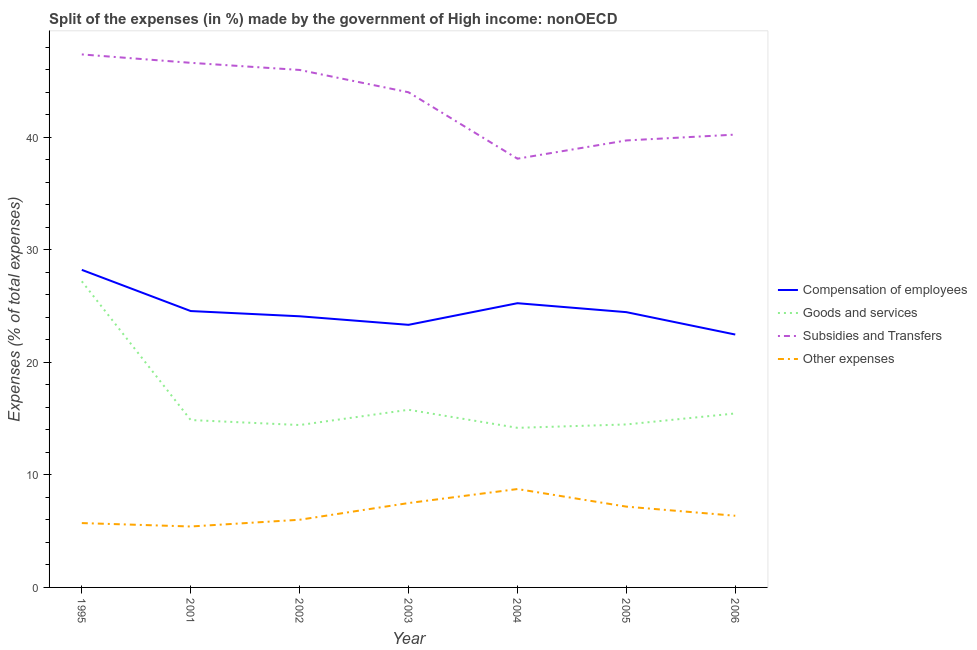Does the line corresponding to percentage of amount spent on compensation of employees intersect with the line corresponding to percentage of amount spent on goods and services?
Keep it short and to the point. No. What is the percentage of amount spent on goods and services in 2002?
Provide a short and direct response. 14.43. Across all years, what is the maximum percentage of amount spent on goods and services?
Your answer should be very brief. 27.2. Across all years, what is the minimum percentage of amount spent on goods and services?
Ensure brevity in your answer.  14.18. What is the total percentage of amount spent on subsidies in the graph?
Your answer should be very brief. 301.95. What is the difference between the percentage of amount spent on other expenses in 2001 and that in 2003?
Your answer should be compact. -2.08. What is the difference between the percentage of amount spent on compensation of employees in 2004 and the percentage of amount spent on other expenses in 2001?
Your answer should be compact. 19.84. What is the average percentage of amount spent on goods and services per year?
Keep it short and to the point. 16.63. In the year 2001, what is the difference between the percentage of amount spent on other expenses and percentage of amount spent on compensation of employees?
Keep it short and to the point. -19.14. In how many years, is the percentage of amount spent on goods and services greater than 44 %?
Make the answer very short. 0. What is the ratio of the percentage of amount spent on compensation of employees in 2002 to that in 2005?
Give a very brief answer. 0.99. Is the difference between the percentage of amount spent on subsidies in 2002 and 2006 greater than the difference between the percentage of amount spent on goods and services in 2002 and 2006?
Your answer should be compact. Yes. What is the difference between the highest and the second highest percentage of amount spent on other expenses?
Provide a succinct answer. 1.25. What is the difference between the highest and the lowest percentage of amount spent on subsidies?
Provide a short and direct response. 9.26. Is the sum of the percentage of amount spent on subsidies in 2001 and 2003 greater than the maximum percentage of amount spent on other expenses across all years?
Your response must be concise. Yes. Is it the case that in every year, the sum of the percentage of amount spent on goods and services and percentage of amount spent on other expenses is greater than the sum of percentage of amount spent on subsidies and percentage of amount spent on compensation of employees?
Your answer should be compact. No. Does the percentage of amount spent on subsidies monotonically increase over the years?
Give a very brief answer. No. Is the percentage of amount spent on other expenses strictly less than the percentage of amount spent on goods and services over the years?
Your answer should be very brief. Yes. How many lines are there?
Your answer should be very brief. 4. How many years are there in the graph?
Keep it short and to the point. 7. Are the values on the major ticks of Y-axis written in scientific E-notation?
Give a very brief answer. No. Does the graph contain any zero values?
Offer a terse response. No. Does the graph contain grids?
Give a very brief answer. No. What is the title of the graph?
Provide a succinct answer. Split of the expenses (in %) made by the government of High income: nonOECD. What is the label or title of the Y-axis?
Give a very brief answer. Expenses (% of total expenses). What is the Expenses (% of total expenses) of Compensation of employees in 1995?
Ensure brevity in your answer.  28.21. What is the Expenses (% of total expenses) in Goods and services in 1995?
Your answer should be very brief. 27.2. What is the Expenses (% of total expenses) of Subsidies and Transfers in 1995?
Your answer should be compact. 47.35. What is the Expenses (% of total expenses) in Other expenses in 1995?
Your response must be concise. 5.72. What is the Expenses (% of total expenses) in Compensation of employees in 2001?
Offer a very short reply. 24.55. What is the Expenses (% of total expenses) of Goods and services in 2001?
Keep it short and to the point. 14.87. What is the Expenses (% of total expenses) of Subsidies and Transfers in 2001?
Give a very brief answer. 46.61. What is the Expenses (% of total expenses) in Other expenses in 2001?
Make the answer very short. 5.41. What is the Expenses (% of total expenses) of Compensation of employees in 2002?
Ensure brevity in your answer.  24.09. What is the Expenses (% of total expenses) of Goods and services in 2002?
Provide a short and direct response. 14.43. What is the Expenses (% of total expenses) in Subsidies and Transfers in 2002?
Keep it short and to the point. 45.97. What is the Expenses (% of total expenses) in Other expenses in 2002?
Give a very brief answer. 6.01. What is the Expenses (% of total expenses) in Compensation of employees in 2003?
Provide a short and direct response. 23.33. What is the Expenses (% of total expenses) in Goods and services in 2003?
Give a very brief answer. 15.78. What is the Expenses (% of total expenses) in Subsidies and Transfers in 2003?
Your response must be concise. 43.99. What is the Expenses (% of total expenses) in Other expenses in 2003?
Make the answer very short. 7.5. What is the Expenses (% of total expenses) of Compensation of employees in 2004?
Offer a terse response. 25.25. What is the Expenses (% of total expenses) in Goods and services in 2004?
Offer a terse response. 14.18. What is the Expenses (% of total expenses) in Subsidies and Transfers in 2004?
Make the answer very short. 38.09. What is the Expenses (% of total expenses) in Other expenses in 2004?
Your response must be concise. 8.74. What is the Expenses (% of total expenses) in Compensation of employees in 2005?
Offer a terse response. 24.46. What is the Expenses (% of total expenses) in Goods and services in 2005?
Offer a very short reply. 14.48. What is the Expenses (% of total expenses) of Subsidies and Transfers in 2005?
Offer a terse response. 39.71. What is the Expenses (% of total expenses) in Other expenses in 2005?
Your answer should be compact. 7.18. What is the Expenses (% of total expenses) in Compensation of employees in 2006?
Keep it short and to the point. 22.47. What is the Expenses (% of total expenses) of Goods and services in 2006?
Keep it short and to the point. 15.46. What is the Expenses (% of total expenses) in Subsidies and Transfers in 2006?
Offer a terse response. 40.23. What is the Expenses (% of total expenses) of Other expenses in 2006?
Make the answer very short. 6.37. Across all years, what is the maximum Expenses (% of total expenses) of Compensation of employees?
Make the answer very short. 28.21. Across all years, what is the maximum Expenses (% of total expenses) of Goods and services?
Ensure brevity in your answer.  27.2. Across all years, what is the maximum Expenses (% of total expenses) in Subsidies and Transfers?
Keep it short and to the point. 47.35. Across all years, what is the maximum Expenses (% of total expenses) in Other expenses?
Provide a short and direct response. 8.74. Across all years, what is the minimum Expenses (% of total expenses) of Compensation of employees?
Your answer should be compact. 22.47. Across all years, what is the minimum Expenses (% of total expenses) of Goods and services?
Your answer should be compact. 14.18. Across all years, what is the minimum Expenses (% of total expenses) in Subsidies and Transfers?
Offer a very short reply. 38.09. Across all years, what is the minimum Expenses (% of total expenses) of Other expenses?
Your answer should be very brief. 5.41. What is the total Expenses (% of total expenses) in Compensation of employees in the graph?
Make the answer very short. 172.36. What is the total Expenses (% of total expenses) in Goods and services in the graph?
Your answer should be compact. 116.39. What is the total Expenses (% of total expenses) of Subsidies and Transfers in the graph?
Keep it short and to the point. 301.95. What is the total Expenses (% of total expenses) in Other expenses in the graph?
Offer a very short reply. 46.92. What is the difference between the Expenses (% of total expenses) of Compensation of employees in 1995 and that in 2001?
Your answer should be very brief. 3.66. What is the difference between the Expenses (% of total expenses) in Goods and services in 1995 and that in 2001?
Offer a terse response. 12.33. What is the difference between the Expenses (% of total expenses) of Subsidies and Transfers in 1995 and that in 2001?
Provide a succinct answer. 0.75. What is the difference between the Expenses (% of total expenses) of Other expenses in 1995 and that in 2001?
Your answer should be very brief. 0.3. What is the difference between the Expenses (% of total expenses) in Compensation of employees in 1995 and that in 2002?
Your answer should be very brief. 4.12. What is the difference between the Expenses (% of total expenses) of Goods and services in 1995 and that in 2002?
Provide a short and direct response. 12.77. What is the difference between the Expenses (% of total expenses) in Subsidies and Transfers in 1995 and that in 2002?
Offer a very short reply. 1.38. What is the difference between the Expenses (% of total expenses) of Other expenses in 1995 and that in 2002?
Make the answer very short. -0.3. What is the difference between the Expenses (% of total expenses) in Compensation of employees in 1995 and that in 2003?
Your answer should be very brief. 4.88. What is the difference between the Expenses (% of total expenses) of Goods and services in 1995 and that in 2003?
Make the answer very short. 11.41. What is the difference between the Expenses (% of total expenses) in Subsidies and Transfers in 1995 and that in 2003?
Offer a terse response. 3.36. What is the difference between the Expenses (% of total expenses) in Other expenses in 1995 and that in 2003?
Your answer should be very brief. -1.78. What is the difference between the Expenses (% of total expenses) in Compensation of employees in 1995 and that in 2004?
Provide a short and direct response. 2.96. What is the difference between the Expenses (% of total expenses) in Goods and services in 1995 and that in 2004?
Give a very brief answer. 13.02. What is the difference between the Expenses (% of total expenses) in Subsidies and Transfers in 1995 and that in 2004?
Keep it short and to the point. 9.26. What is the difference between the Expenses (% of total expenses) of Other expenses in 1995 and that in 2004?
Offer a terse response. -3.02. What is the difference between the Expenses (% of total expenses) in Compensation of employees in 1995 and that in 2005?
Your answer should be very brief. 3.76. What is the difference between the Expenses (% of total expenses) in Goods and services in 1995 and that in 2005?
Make the answer very short. 12.72. What is the difference between the Expenses (% of total expenses) of Subsidies and Transfers in 1995 and that in 2005?
Provide a succinct answer. 7.64. What is the difference between the Expenses (% of total expenses) in Other expenses in 1995 and that in 2005?
Provide a short and direct response. -1.46. What is the difference between the Expenses (% of total expenses) of Compensation of employees in 1995 and that in 2006?
Provide a succinct answer. 5.75. What is the difference between the Expenses (% of total expenses) of Goods and services in 1995 and that in 2006?
Ensure brevity in your answer.  11.74. What is the difference between the Expenses (% of total expenses) of Subsidies and Transfers in 1995 and that in 2006?
Ensure brevity in your answer.  7.12. What is the difference between the Expenses (% of total expenses) in Other expenses in 1995 and that in 2006?
Offer a terse response. -0.65. What is the difference between the Expenses (% of total expenses) of Compensation of employees in 2001 and that in 2002?
Give a very brief answer. 0.46. What is the difference between the Expenses (% of total expenses) in Goods and services in 2001 and that in 2002?
Keep it short and to the point. 0.44. What is the difference between the Expenses (% of total expenses) of Subsidies and Transfers in 2001 and that in 2002?
Your answer should be very brief. 0.63. What is the difference between the Expenses (% of total expenses) of Other expenses in 2001 and that in 2002?
Keep it short and to the point. -0.6. What is the difference between the Expenses (% of total expenses) of Compensation of employees in 2001 and that in 2003?
Offer a terse response. 1.22. What is the difference between the Expenses (% of total expenses) in Goods and services in 2001 and that in 2003?
Ensure brevity in your answer.  -0.91. What is the difference between the Expenses (% of total expenses) in Subsidies and Transfers in 2001 and that in 2003?
Offer a terse response. 2.62. What is the difference between the Expenses (% of total expenses) of Other expenses in 2001 and that in 2003?
Offer a terse response. -2.08. What is the difference between the Expenses (% of total expenses) in Compensation of employees in 2001 and that in 2004?
Your response must be concise. -0.7. What is the difference between the Expenses (% of total expenses) of Goods and services in 2001 and that in 2004?
Your answer should be very brief. 0.69. What is the difference between the Expenses (% of total expenses) of Subsidies and Transfers in 2001 and that in 2004?
Offer a terse response. 8.52. What is the difference between the Expenses (% of total expenses) in Other expenses in 2001 and that in 2004?
Offer a very short reply. -3.33. What is the difference between the Expenses (% of total expenses) of Compensation of employees in 2001 and that in 2005?
Make the answer very short. 0.1. What is the difference between the Expenses (% of total expenses) in Goods and services in 2001 and that in 2005?
Your answer should be compact. 0.39. What is the difference between the Expenses (% of total expenses) of Subsidies and Transfers in 2001 and that in 2005?
Give a very brief answer. 6.9. What is the difference between the Expenses (% of total expenses) of Other expenses in 2001 and that in 2005?
Your answer should be compact. -1.76. What is the difference between the Expenses (% of total expenses) in Compensation of employees in 2001 and that in 2006?
Offer a terse response. 2.09. What is the difference between the Expenses (% of total expenses) in Goods and services in 2001 and that in 2006?
Keep it short and to the point. -0.58. What is the difference between the Expenses (% of total expenses) of Subsidies and Transfers in 2001 and that in 2006?
Offer a terse response. 6.38. What is the difference between the Expenses (% of total expenses) in Other expenses in 2001 and that in 2006?
Keep it short and to the point. -0.95. What is the difference between the Expenses (% of total expenses) in Compensation of employees in 2002 and that in 2003?
Your response must be concise. 0.76. What is the difference between the Expenses (% of total expenses) of Goods and services in 2002 and that in 2003?
Provide a succinct answer. -1.36. What is the difference between the Expenses (% of total expenses) of Subsidies and Transfers in 2002 and that in 2003?
Your response must be concise. 1.98. What is the difference between the Expenses (% of total expenses) in Other expenses in 2002 and that in 2003?
Make the answer very short. -1.48. What is the difference between the Expenses (% of total expenses) of Compensation of employees in 2002 and that in 2004?
Offer a very short reply. -1.16. What is the difference between the Expenses (% of total expenses) of Goods and services in 2002 and that in 2004?
Keep it short and to the point. 0.25. What is the difference between the Expenses (% of total expenses) of Subsidies and Transfers in 2002 and that in 2004?
Keep it short and to the point. 7.88. What is the difference between the Expenses (% of total expenses) in Other expenses in 2002 and that in 2004?
Your response must be concise. -2.73. What is the difference between the Expenses (% of total expenses) of Compensation of employees in 2002 and that in 2005?
Offer a terse response. -0.37. What is the difference between the Expenses (% of total expenses) in Goods and services in 2002 and that in 2005?
Your answer should be very brief. -0.05. What is the difference between the Expenses (% of total expenses) of Subsidies and Transfers in 2002 and that in 2005?
Offer a very short reply. 6.26. What is the difference between the Expenses (% of total expenses) of Other expenses in 2002 and that in 2005?
Give a very brief answer. -1.17. What is the difference between the Expenses (% of total expenses) of Compensation of employees in 2002 and that in 2006?
Keep it short and to the point. 1.62. What is the difference between the Expenses (% of total expenses) of Goods and services in 2002 and that in 2006?
Give a very brief answer. -1.03. What is the difference between the Expenses (% of total expenses) of Subsidies and Transfers in 2002 and that in 2006?
Your response must be concise. 5.74. What is the difference between the Expenses (% of total expenses) in Other expenses in 2002 and that in 2006?
Give a very brief answer. -0.35. What is the difference between the Expenses (% of total expenses) of Compensation of employees in 2003 and that in 2004?
Ensure brevity in your answer.  -1.92. What is the difference between the Expenses (% of total expenses) of Goods and services in 2003 and that in 2004?
Your response must be concise. 1.6. What is the difference between the Expenses (% of total expenses) in Subsidies and Transfers in 2003 and that in 2004?
Ensure brevity in your answer.  5.9. What is the difference between the Expenses (% of total expenses) in Other expenses in 2003 and that in 2004?
Offer a very short reply. -1.25. What is the difference between the Expenses (% of total expenses) in Compensation of employees in 2003 and that in 2005?
Make the answer very short. -1.13. What is the difference between the Expenses (% of total expenses) in Goods and services in 2003 and that in 2005?
Offer a terse response. 1.3. What is the difference between the Expenses (% of total expenses) in Subsidies and Transfers in 2003 and that in 2005?
Give a very brief answer. 4.28. What is the difference between the Expenses (% of total expenses) in Other expenses in 2003 and that in 2005?
Make the answer very short. 0.32. What is the difference between the Expenses (% of total expenses) in Compensation of employees in 2003 and that in 2006?
Ensure brevity in your answer.  0.86. What is the difference between the Expenses (% of total expenses) of Goods and services in 2003 and that in 2006?
Keep it short and to the point. 0.33. What is the difference between the Expenses (% of total expenses) in Subsidies and Transfers in 2003 and that in 2006?
Offer a terse response. 3.76. What is the difference between the Expenses (% of total expenses) in Other expenses in 2003 and that in 2006?
Your answer should be very brief. 1.13. What is the difference between the Expenses (% of total expenses) in Compensation of employees in 2004 and that in 2005?
Ensure brevity in your answer.  0.79. What is the difference between the Expenses (% of total expenses) of Goods and services in 2004 and that in 2005?
Give a very brief answer. -0.3. What is the difference between the Expenses (% of total expenses) in Subsidies and Transfers in 2004 and that in 2005?
Offer a terse response. -1.62. What is the difference between the Expenses (% of total expenses) in Other expenses in 2004 and that in 2005?
Ensure brevity in your answer.  1.56. What is the difference between the Expenses (% of total expenses) of Compensation of employees in 2004 and that in 2006?
Give a very brief answer. 2.78. What is the difference between the Expenses (% of total expenses) of Goods and services in 2004 and that in 2006?
Offer a very short reply. -1.28. What is the difference between the Expenses (% of total expenses) of Subsidies and Transfers in 2004 and that in 2006?
Ensure brevity in your answer.  -2.14. What is the difference between the Expenses (% of total expenses) of Other expenses in 2004 and that in 2006?
Your answer should be very brief. 2.37. What is the difference between the Expenses (% of total expenses) of Compensation of employees in 2005 and that in 2006?
Offer a very short reply. 1.99. What is the difference between the Expenses (% of total expenses) in Goods and services in 2005 and that in 2006?
Keep it short and to the point. -0.98. What is the difference between the Expenses (% of total expenses) of Subsidies and Transfers in 2005 and that in 2006?
Your answer should be very brief. -0.52. What is the difference between the Expenses (% of total expenses) in Other expenses in 2005 and that in 2006?
Make the answer very short. 0.81. What is the difference between the Expenses (% of total expenses) of Compensation of employees in 1995 and the Expenses (% of total expenses) of Goods and services in 2001?
Offer a terse response. 13.34. What is the difference between the Expenses (% of total expenses) of Compensation of employees in 1995 and the Expenses (% of total expenses) of Subsidies and Transfers in 2001?
Provide a succinct answer. -18.39. What is the difference between the Expenses (% of total expenses) in Compensation of employees in 1995 and the Expenses (% of total expenses) in Other expenses in 2001?
Your answer should be very brief. 22.8. What is the difference between the Expenses (% of total expenses) in Goods and services in 1995 and the Expenses (% of total expenses) in Subsidies and Transfers in 2001?
Ensure brevity in your answer.  -19.41. What is the difference between the Expenses (% of total expenses) of Goods and services in 1995 and the Expenses (% of total expenses) of Other expenses in 2001?
Offer a terse response. 21.78. What is the difference between the Expenses (% of total expenses) in Subsidies and Transfers in 1995 and the Expenses (% of total expenses) in Other expenses in 2001?
Give a very brief answer. 41.94. What is the difference between the Expenses (% of total expenses) of Compensation of employees in 1995 and the Expenses (% of total expenses) of Goods and services in 2002?
Ensure brevity in your answer.  13.79. What is the difference between the Expenses (% of total expenses) in Compensation of employees in 1995 and the Expenses (% of total expenses) in Subsidies and Transfers in 2002?
Make the answer very short. -17.76. What is the difference between the Expenses (% of total expenses) of Compensation of employees in 1995 and the Expenses (% of total expenses) of Other expenses in 2002?
Provide a short and direct response. 22.2. What is the difference between the Expenses (% of total expenses) of Goods and services in 1995 and the Expenses (% of total expenses) of Subsidies and Transfers in 2002?
Offer a terse response. -18.78. What is the difference between the Expenses (% of total expenses) in Goods and services in 1995 and the Expenses (% of total expenses) in Other expenses in 2002?
Ensure brevity in your answer.  21.18. What is the difference between the Expenses (% of total expenses) in Subsidies and Transfers in 1995 and the Expenses (% of total expenses) in Other expenses in 2002?
Your answer should be very brief. 41.34. What is the difference between the Expenses (% of total expenses) in Compensation of employees in 1995 and the Expenses (% of total expenses) in Goods and services in 2003?
Give a very brief answer. 12.43. What is the difference between the Expenses (% of total expenses) of Compensation of employees in 1995 and the Expenses (% of total expenses) of Subsidies and Transfers in 2003?
Ensure brevity in your answer.  -15.78. What is the difference between the Expenses (% of total expenses) of Compensation of employees in 1995 and the Expenses (% of total expenses) of Other expenses in 2003?
Provide a succinct answer. 20.72. What is the difference between the Expenses (% of total expenses) in Goods and services in 1995 and the Expenses (% of total expenses) in Subsidies and Transfers in 2003?
Provide a short and direct response. -16.79. What is the difference between the Expenses (% of total expenses) in Goods and services in 1995 and the Expenses (% of total expenses) in Other expenses in 2003?
Your response must be concise. 19.7. What is the difference between the Expenses (% of total expenses) of Subsidies and Transfers in 1995 and the Expenses (% of total expenses) of Other expenses in 2003?
Give a very brief answer. 39.86. What is the difference between the Expenses (% of total expenses) in Compensation of employees in 1995 and the Expenses (% of total expenses) in Goods and services in 2004?
Make the answer very short. 14.03. What is the difference between the Expenses (% of total expenses) in Compensation of employees in 1995 and the Expenses (% of total expenses) in Subsidies and Transfers in 2004?
Keep it short and to the point. -9.88. What is the difference between the Expenses (% of total expenses) in Compensation of employees in 1995 and the Expenses (% of total expenses) in Other expenses in 2004?
Ensure brevity in your answer.  19.47. What is the difference between the Expenses (% of total expenses) of Goods and services in 1995 and the Expenses (% of total expenses) of Subsidies and Transfers in 2004?
Make the answer very short. -10.89. What is the difference between the Expenses (% of total expenses) in Goods and services in 1995 and the Expenses (% of total expenses) in Other expenses in 2004?
Provide a succinct answer. 18.46. What is the difference between the Expenses (% of total expenses) of Subsidies and Transfers in 1995 and the Expenses (% of total expenses) of Other expenses in 2004?
Provide a short and direct response. 38.61. What is the difference between the Expenses (% of total expenses) of Compensation of employees in 1995 and the Expenses (% of total expenses) of Goods and services in 2005?
Your response must be concise. 13.73. What is the difference between the Expenses (% of total expenses) in Compensation of employees in 1995 and the Expenses (% of total expenses) in Subsidies and Transfers in 2005?
Offer a terse response. -11.5. What is the difference between the Expenses (% of total expenses) of Compensation of employees in 1995 and the Expenses (% of total expenses) of Other expenses in 2005?
Provide a short and direct response. 21.04. What is the difference between the Expenses (% of total expenses) in Goods and services in 1995 and the Expenses (% of total expenses) in Subsidies and Transfers in 2005?
Provide a short and direct response. -12.51. What is the difference between the Expenses (% of total expenses) of Goods and services in 1995 and the Expenses (% of total expenses) of Other expenses in 2005?
Give a very brief answer. 20.02. What is the difference between the Expenses (% of total expenses) of Subsidies and Transfers in 1995 and the Expenses (% of total expenses) of Other expenses in 2005?
Ensure brevity in your answer.  40.17. What is the difference between the Expenses (% of total expenses) in Compensation of employees in 1995 and the Expenses (% of total expenses) in Goods and services in 2006?
Provide a succinct answer. 12.76. What is the difference between the Expenses (% of total expenses) in Compensation of employees in 1995 and the Expenses (% of total expenses) in Subsidies and Transfers in 2006?
Offer a very short reply. -12.02. What is the difference between the Expenses (% of total expenses) in Compensation of employees in 1995 and the Expenses (% of total expenses) in Other expenses in 2006?
Offer a very short reply. 21.85. What is the difference between the Expenses (% of total expenses) of Goods and services in 1995 and the Expenses (% of total expenses) of Subsidies and Transfers in 2006?
Ensure brevity in your answer.  -13.03. What is the difference between the Expenses (% of total expenses) in Goods and services in 1995 and the Expenses (% of total expenses) in Other expenses in 2006?
Give a very brief answer. 20.83. What is the difference between the Expenses (% of total expenses) of Subsidies and Transfers in 1995 and the Expenses (% of total expenses) of Other expenses in 2006?
Give a very brief answer. 40.99. What is the difference between the Expenses (% of total expenses) of Compensation of employees in 2001 and the Expenses (% of total expenses) of Goods and services in 2002?
Give a very brief answer. 10.13. What is the difference between the Expenses (% of total expenses) in Compensation of employees in 2001 and the Expenses (% of total expenses) in Subsidies and Transfers in 2002?
Offer a terse response. -21.42. What is the difference between the Expenses (% of total expenses) of Compensation of employees in 2001 and the Expenses (% of total expenses) of Other expenses in 2002?
Make the answer very short. 18.54. What is the difference between the Expenses (% of total expenses) in Goods and services in 2001 and the Expenses (% of total expenses) in Subsidies and Transfers in 2002?
Your answer should be very brief. -31.1. What is the difference between the Expenses (% of total expenses) in Goods and services in 2001 and the Expenses (% of total expenses) in Other expenses in 2002?
Make the answer very short. 8.86. What is the difference between the Expenses (% of total expenses) of Subsidies and Transfers in 2001 and the Expenses (% of total expenses) of Other expenses in 2002?
Give a very brief answer. 40.59. What is the difference between the Expenses (% of total expenses) of Compensation of employees in 2001 and the Expenses (% of total expenses) of Goods and services in 2003?
Ensure brevity in your answer.  8.77. What is the difference between the Expenses (% of total expenses) of Compensation of employees in 2001 and the Expenses (% of total expenses) of Subsidies and Transfers in 2003?
Give a very brief answer. -19.44. What is the difference between the Expenses (% of total expenses) of Compensation of employees in 2001 and the Expenses (% of total expenses) of Other expenses in 2003?
Provide a succinct answer. 17.06. What is the difference between the Expenses (% of total expenses) of Goods and services in 2001 and the Expenses (% of total expenses) of Subsidies and Transfers in 2003?
Your answer should be compact. -29.12. What is the difference between the Expenses (% of total expenses) in Goods and services in 2001 and the Expenses (% of total expenses) in Other expenses in 2003?
Your response must be concise. 7.38. What is the difference between the Expenses (% of total expenses) in Subsidies and Transfers in 2001 and the Expenses (% of total expenses) in Other expenses in 2003?
Offer a very short reply. 39.11. What is the difference between the Expenses (% of total expenses) of Compensation of employees in 2001 and the Expenses (% of total expenses) of Goods and services in 2004?
Ensure brevity in your answer.  10.38. What is the difference between the Expenses (% of total expenses) in Compensation of employees in 2001 and the Expenses (% of total expenses) in Subsidies and Transfers in 2004?
Keep it short and to the point. -13.54. What is the difference between the Expenses (% of total expenses) of Compensation of employees in 2001 and the Expenses (% of total expenses) of Other expenses in 2004?
Your response must be concise. 15.81. What is the difference between the Expenses (% of total expenses) in Goods and services in 2001 and the Expenses (% of total expenses) in Subsidies and Transfers in 2004?
Give a very brief answer. -23.22. What is the difference between the Expenses (% of total expenses) of Goods and services in 2001 and the Expenses (% of total expenses) of Other expenses in 2004?
Your response must be concise. 6.13. What is the difference between the Expenses (% of total expenses) of Subsidies and Transfers in 2001 and the Expenses (% of total expenses) of Other expenses in 2004?
Provide a short and direct response. 37.87. What is the difference between the Expenses (% of total expenses) in Compensation of employees in 2001 and the Expenses (% of total expenses) in Goods and services in 2005?
Your response must be concise. 10.08. What is the difference between the Expenses (% of total expenses) in Compensation of employees in 2001 and the Expenses (% of total expenses) in Subsidies and Transfers in 2005?
Your answer should be compact. -15.16. What is the difference between the Expenses (% of total expenses) in Compensation of employees in 2001 and the Expenses (% of total expenses) in Other expenses in 2005?
Provide a short and direct response. 17.38. What is the difference between the Expenses (% of total expenses) in Goods and services in 2001 and the Expenses (% of total expenses) in Subsidies and Transfers in 2005?
Give a very brief answer. -24.84. What is the difference between the Expenses (% of total expenses) in Goods and services in 2001 and the Expenses (% of total expenses) in Other expenses in 2005?
Make the answer very short. 7.69. What is the difference between the Expenses (% of total expenses) of Subsidies and Transfers in 2001 and the Expenses (% of total expenses) of Other expenses in 2005?
Your answer should be very brief. 39.43. What is the difference between the Expenses (% of total expenses) in Compensation of employees in 2001 and the Expenses (% of total expenses) in Goods and services in 2006?
Offer a very short reply. 9.1. What is the difference between the Expenses (% of total expenses) of Compensation of employees in 2001 and the Expenses (% of total expenses) of Subsidies and Transfers in 2006?
Your answer should be compact. -15.68. What is the difference between the Expenses (% of total expenses) in Compensation of employees in 2001 and the Expenses (% of total expenses) in Other expenses in 2006?
Your answer should be very brief. 18.19. What is the difference between the Expenses (% of total expenses) in Goods and services in 2001 and the Expenses (% of total expenses) in Subsidies and Transfers in 2006?
Offer a terse response. -25.36. What is the difference between the Expenses (% of total expenses) of Goods and services in 2001 and the Expenses (% of total expenses) of Other expenses in 2006?
Ensure brevity in your answer.  8.5. What is the difference between the Expenses (% of total expenses) in Subsidies and Transfers in 2001 and the Expenses (% of total expenses) in Other expenses in 2006?
Ensure brevity in your answer.  40.24. What is the difference between the Expenses (% of total expenses) in Compensation of employees in 2002 and the Expenses (% of total expenses) in Goods and services in 2003?
Offer a terse response. 8.31. What is the difference between the Expenses (% of total expenses) in Compensation of employees in 2002 and the Expenses (% of total expenses) in Subsidies and Transfers in 2003?
Your answer should be compact. -19.9. What is the difference between the Expenses (% of total expenses) of Compensation of employees in 2002 and the Expenses (% of total expenses) of Other expenses in 2003?
Provide a succinct answer. 16.59. What is the difference between the Expenses (% of total expenses) in Goods and services in 2002 and the Expenses (% of total expenses) in Subsidies and Transfers in 2003?
Your answer should be very brief. -29.56. What is the difference between the Expenses (% of total expenses) in Goods and services in 2002 and the Expenses (% of total expenses) in Other expenses in 2003?
Keep it short and to the point. 6.93. What is the difference between the Expenses (% of total expenses) in Subsidies and Transfers in 2002 and the Expenses (% of total expenses) in Other expenses in 2003?
Your response must be concise. 38.48. What is the difference between the Expenses (% of total expenses) in Compensation of employees in 2002 and the Expenses (% of total expenses) in Goods and services in 2004?
Provide a succinct answer. 9.91. What is the difference between the Expenses (% of total expenses) in Compensation of employees in 2002 and the Expenses (% of total expenses) in Subsidies and Transfers in 2004?
Your response must be concise. -14. What is the difference between the Expenses (% of total expenses) in Compensation of employees in 2002 and the Expenses (% of total expenses) in Other expenses in 2004?
Your answer should be very brief. 15.35. What is the difference between the Expenses (% of total expenses) of Goods and services in 2002 and the Expenses (% of total expenses) of Subsidies and Transfers in 2004?
Make the answer very short. -23.66. What is the difference between the Expenses (% of total expenses) in Goods and services in 2002 and the Expenses (% of total expenses) in Other expenses in 2004?
Ensure brevity in your answer.  5.69. What is the difference between the Expenses (% of total expenses) in Subsidies and Transfers in 2002 and the Expenses (% of total expenses) in Other expenses in 2004?
Offer a very short reply. 37.23. What is the difference between the Expenses (% of total expenses) in Compensation of employees in 2002 and the Expenses (% of total expenses) in Goods and services in 2005?
Give a very brief answer. 9.61. What is the difference between the Expenses (% of total expenses) in Compensation of employees in 2002 and the Expenses (% of total expenses) in Subsidies and Transfers in 2005?
Offer a very short reply. -15.62. What is the difference between the Expenses (% of total expenses) in Compensation of employees in 2002 and the Expenses (% of total expenses) in Other expenses in 2005?
Provide a succinct answer. 16.91. What is the difference between the Expenses (% of total expenses) in Goods and services in 2002 and the Expenses (% of total expenses) in Subsidies and Transfers in 2005?
Keep it short and to the point. -25.28. What is the difference between the Expenses (% of total expenses) in Goods and services in 2002 and the Expenses (% of total expenses) in Other expenses in 2005?
Provide a succinct answer. 7.25. What is the difference between the Expenses (% of total expenses) in Subsidies and Transfers in 2002 and the Expenses (% of total expenses) in Other expenses in 2005?
Give a very brief answer. 38.79. What is the difference between the Expenses (% of total expenses) in Compensation of employees in 2002 and the Expenses (% of total expenses) in Goods and services in 2006?
Make the answer very short. 8.63. What is the difference between the Expenses (% of total expenses) of Compensation of employees in 2002 and the Expenses (% of total expenses) of Subsidies and Transfers in 2006?
Provide a short and direct response. -16.14. What is the difference between the Expenses (% of total expenses) in Compensation of employees in 2002 and the Expenses (% of total expenses) in Other expenses in 2006?
Ensure brevity in your answer.  17.72. What is the difference between the Expenses (% of total expenses) of Goods and services in 2002 and the Expenses (% of total expenses) of Subsidies and Transfers in 2006?
Give a very brief answer. -25.8. What is the difference between the Expenses (% of total expenses) of Goods and services in 2002 and the Expenses (% of total expenses) of Other expenses in 2006?
Your answer should be very brief. 8.06. What is the difference between the Expenses (% of total expenses) of Subsidies and Transfers in 2002 and the Expenses (% of total expenses) of Other expenses in 2006?
Provide a succinct answer. 39.61. What is the difference between the Expenses (% of total expenses) of Compensation of employees in 2003 and the Expenses (% of total expenses) of Goods and services in 2004?
Make the answer very short. 9.15. What is the difference between the Expenses (% of total expenses) of Compensation of employees in 2003 and the Expenses (% of total expenses) of Subsidies and Transfers in 2004?
Provide a succinct answer. -14.76. What is the difference between the Expenses (% of total expenses) in Compensation of employees in 2003 and the Expenses (% of total expenses) in Other expenses in 2004?
Your answer should be very brief. 14.59. What is the difference between the Expenses (% of total expenses) in Goods and services in 2003 and the Expenses (% of total expenses) in Subsidies and Transfers in 2004?
Your response must be concise. -22.31. What is the difference between the Expenses (% of total expenses) in Goods and services in 2003 and the Expenses (% of total expenses) in Other expenses in 2004?
Your answer should be very brief. 7.04. What is the difference between the Expenses (% of total expenses) in Subsidies and Transfers in 2003 and the Expenses (% of total expenses) in Other expenses in 2004?
Offer a very short reply. 35.25. What is the difference between the Expenses (% of total expenses) in Compensation of employees in 2003 and the Expenses (% of total expenses) in Goods and services in 2005?
Ensure brevity in your answer.  8.85. What is the difference between the Expenses (% of total expenses) of Compensation of employees in 2003 and the Expenses (% of total expenses) of Subsidies and Transfers in 2005?
Keep it short and to the point. -16.38. What is the difference between the Expenses (% of total expenses) in Compensation of employees in 2003 and the Expenses (% of total expenses) in Other expenses in 2005?
Your response must be concise. 16.15. What is the difference between the Expenses (% of total expenses) of Goods and services in 2003 and the Expenses (% of total expenses) of Subsidies and Transfers in 2005?
Offer a terse response. -23.93. What is the difference between the Expenses (% of total expenses) of Goods and services in 2003 and the Expenses (% of total expenses) of Other expenses in 2005?
Keep it short and to the point. 8.61. What is the difference between the Expenses (% of total expenses) of Subsidies and Transfers in 2003 and the Expenses (% of total expenses) of Other expenses in 2005?
Offer a terse response. 36.81. What is the difference between the Expenses (% of total expenses) in Compensation of employees in 2003 and the Expenses (% of total expenses) in Goods and services in 2006?
Your answer should be very brief. 7.87. What is the difference between the Expenses (% of total expenses) in Compensation of employees in 2003 and the Expenses (% of total expenses) in Subsidies and Transfers in 2006?
Ensure brevity in your answer.  -16.9. What is the difference between the Expenses (% of total expenses) in Compensation of employees in 2003 and the Expenses (% of total expenses) in Other expenses in 2006?
Provide a succinct answer. 16.96. What is the difference between the Expenses (% of total expenses) of Goods and services in 2003 and the Expenses (% of total expenses) of Subsidies and Transfers in 2006?
Ensure brevity in your answer.  -24.45. What is the difference between the Expenses (% of total expenses) in Goods and services in 2003 and the Expenses (% of total expenses) in Other expenses in 2006?
Make the answer very short. 9.42. What is the difference between the Expenses (% of total expenses) of Subsidies and Transfers in 2003 and the Expenses (% of total expenses) of Other expenses in 2006?
Your response must be concise. 37.62. What is the difference between the Expenses (% of total expenses) in Compensation of employees in 2004 and the Expenses (% of total expenses) in Goods and services in 2005?
Provide a short and direct response. 10.77. What is the difference between the Expenses (% of total expenses) of Compensation of employees in 2004 and the Expenses (% of total expenses) of Subsidies and Transfers in 2005?
Give a very brief answer. -14.46. What is the difference between the Expenses (% of total expenses) in Compensation of employees in 2004 and the Expenses (% of total expenses) in Other expenses in 2005?
Offer a very short reply. 18.07. What is the difference between the Expenses (% of total expenses) in Goods and services in 2004 and the Expenses (% of total expenses) in Subsidies and Transfers in 2005?
Provide a succinct answer. -25.53. What is the difference between the Expenses (% of total expenses) in Goods and services in 2004 and the Expenses (% of total expenses) in Other expenses in 2005?
Make the answer very short. 7. What is the difference between the Expenses (% of total expenses) of Subsidies and Transfers in 2004 and the Expenses (% of total expenses) of Other expenses in 2005?
Offer a very short reply. 30.91. What is the difference between the Expenses (% of total expenses) in Compensation of employees in 2004 and the Expenses (% of total expenses) in Goods and services in 2006?
Offer a terse response. 9.79. What is the difference between the Expenses (% of total expenses) in Compensation of employees in 2004 and the Expenses (% of total expenses) in Subsidies and Transfers in 2006?
Provide a succinct answer. -14.98. What is the difference between the Expenses (% of total expenses) in Compensation of employees in 2004 and the Expenses (% of total expenses) in Other expenses in 2006?
Provide a short and direct response. 18.88. What is the difference between the Expenses (% of total expenses) of Goods and services in 2004 and the Expenses (% of total expenses) of Subsidies and Transfers in 2006?
Offer a terse response. -26.05. What is the difference between the Expenses (% of total expenses) of Goods and services in 2004 and the Expenses (% of total expenses) of Other expenses in 2006?
Your answer should be compact. 7.81. What is the difference between the Expenses (% of total expenses) in Subsidies and Transfers in 2004 and the Expenses (% of total expenses) in Other expenses in 2006?
Keep it short and to the point. 31.72. What is the difference between the Expenses (% of total expenses) in Compensation of employees in 2005 and the Expenses (% of total expenses) in Goods and services in 2006?
Give a very brief answer. 9. What is the difference between the Expenses (% of total expenses) in Compensation of employees in 2005 and the Expenses (% of total expenses) in Subsidies and Transfers in 2006?
Offer a very short reply. -15.77. What is the difference between the Expenses (% of total expenses) in Compensation of employees in 2005 and the Expenses (% of total expenses) in Other expenses in 2006?
Offer a terse response. 18.09. What is the difference between the Expenses (% of total expenses) in Goods and services in 2005 and the Expenses (% of total expenses) in Subsidies and Transfers in 2006?
Offer a very short reply. -25.75. What is the difference between the Expenses (% of total expenses) of Goods and services in 2005 and the Expenses (% of total expenses) of Other expenses in 2006?
Offer a very short reply. 8.11. What is the difference between the Expenses (% of total expenses) of Subsidies and Transfers in 2005 and the Expenses (% of total expenses) of Other expenses in 2006?
Keep it short and to the point. 33.34. What is the average Expenses (% of total expenses) in Compensation of employees per year?
Offer a very short reply. 24.62. What is the average Expenses (% of total expenses) of Goods and services per year?
Provide a short and direct response. 16.63. What is the average Expenses (% of total expenses) in Subsidies and Transfers per year?
Give a very brief answer. 43.14. What is the average Expenses (% of total expenses) of Other expenses per year?
Ensure brevity in your answer.  6.7. In the year 1995, what is the difference between the Expenses (% of total expenses) in Compensation of employees and Expenses (% of total expenses) in Goods and services?
Offer a terse response. 1.02. In the year 1995, what is the difference between the Expenses (% of total expenses) of Compensation of employees and Expenses (% of total expenses) of Subsidies and Transfers?
Give a very brief answer. -19.14. In the year 1995, what is the difference between the Expenses (% of total expenses) of Compensation of employees and Expenses (% of total expenses) of Other expenses?
Make the answer very short. 22.5. In the year 1995, what is the difference between the Expenses (% of total expenses) in Goods and services and Expenses (% of total expenses) in Subsidies and Transfers?
Provide a short and direct response. -20.16. In the year 1995, what is the difference between the Expenses (% of total expenses) in Goods and services and Expenses (% of total expenses) in Other expenses?
Ensure brevity in your answer.  21.48. In the year 1995, what is the difference between the Expenses (% of total expenses) of Subsidies and Transfers and Expenses (% of total expenses) of Other expenses?
Offer a terse response. 41.64. In the year 2001, what is the difference between the Expenses (% of total expenses) in Compensation of employees and Expenses (% of total expenses) in Goods and services?
Offer a very short reply. 9.68. In the year 2001, what is the difference between the Expenses (% of total expenses) of Compensation of employees and Expenses (% of total expenses) of Subsidies and Transfers?
Your answer should be very brief. -22.05. In the year 2001, what is the difference between the Expenses (% of total expenses) in Compensation of employees and Expenses (% of total expenses) in Other expenses?
Keep it short and to the point. 19.14. In the year 2001, what is the difference between the Expenses (% of total expenses) of Goods and services and Expenses (% of total expenses) of Subsidies and Transfers?
Give a very brief answer. -31.74. In the year 2001, what is the difference between the Expenses (% of total expenses) in Goods and services and Expenses (% of total expenses) in Other expenses?
Provide a succinct answer. 9.46. In the year 2001, what is the difference between the Expenses (% of total expenses) in Subsidies and Transfers and Expenses (% of total expenses) in Other expenses?
Offer a very short reply. 41.19. In the year 2002, what is the difference between the Expenses (% of total expenses) of Compensation of employees and Expenses (% of total expenses) of Goods and services?
Ensure brevity in your answer.  9.66. In the year 2002, what is the difference between the Expenses (% of total expenses) in Compensation of employees and Expenses (% of total expenses) in Subsidies and Transfers?
Provide a short and direct response. -21.88. In the year 2002, what is the difference between the Expenses (% of total expenses) in Compensation of employees and Expenses (% of total expenses) in Other expenses?
Your answer should be very brief. 18.08. In the year 2002, what is the difference between the Expenses (% of total expenses) of Goods and services and Expenses (% of total expenses) of Subsidies and Transfers?
Offer a very short reply. -31.55. In the year 2002, what is the difference between the Expenses (% of total expenses) of Goods and services and Expenses (% of total expenses) of Other expenses?
Your answer should be very brief. 8.41. In the year 2002, what is the difference between the Expenses (% of total expenses) in Subsidies and Transfers and Expenses (% of total expenses) in Other expenses?
Make the answer very short. 39.96. In the year 2003, what is the difference between the Expenses (% of total expenses) in Compensation of employees and Expenses (% of total expenses) in Goods and services?
Offer a very short reply. 7.55. In the year 2003, what is the difference between the Expenses (% of total expenses) in Compensation of employees and Expenses (% of total expenses) in Subsidies and Transfers?
Make the answer very short. -20.66. In the year 2003, what is the difference between the Expenses (% of total expenses) in Compensation of employees and Expenses (% of total expenses) in Other expenses?
Keep it short and to the point. 15.83. In the year 2003, what is the difference between the Expenses (% of total expenses) of Goods and services and Expenses (% of total expenses) of Subsidies and Transfers?
Provide a short and direct response. -28.21. In the year 2003, what is the difference between the Expenses (% of total expenses) in Goods and services and Expenses (% of total expenses) in Other expenses?
Your response must be concise. 8.29. In the year 2003, what is the difference between the Expenses (% of total expenses) in Subsidies and Transfers and Expenses (% of total expenses) in Other expenses?
Make the answer very short. 36.5. In the year 2004, what is the difference between the Expenses (% of total expenses) of Compensation of employees and Expenses (% of total expenses) of Goods and services?
Your response must be concise. 11.07. In the year 2004, what is the difference between the Expenses (% of total expenses) of Compensation of employees and Expenses (% of total expenses) of Subsidies and Transfers?
Your answer should be very brief. -12.84. In the year 2004, what is the difference between the Expenses (% of total expenses) of Compensation of employees and Expenses (% of total expenses) of Other expenses?
Ensure brevity in your answer.  16.51. In the year 2004, what is the difference between the Expenses (% of total expenses) in Goods and services and Expenses (% of total expenses) in Subsidies and Transfers?
Offer a terse response. -23.91. In the year 2004, what is the difference between the Expenses (% of total expenses) of Goods and services and Expenses (% of total expenses) of Other expenses?
Provide a succinct answer. 5.44. In the year 2004, what is the difference between the Expenses (% of total expenses) of Subsidies and Transfers and Expenses (% of total expenses) of Other expenses?
Make the answer very short. 29.35. In the year 2005, what is the difference between the Expenses (% of total expenses) of Compensation of employees and Expenses (% of total expenses) of Goods and services?
Your answer should be very brief. 9.98. In the year 2005, what is the difference between the Expenses (% of total expenses) of Compensation of employees and Expenses (% of total expenses) of Subsidies and Transfers?
Make the answer very short. -15.25. In the year 2005, what is the difference between the Expenses (% of total expenses) in Compensation of employees and Expenses (% of total expenses) in Other expenses?
Offer a terse response. 17.28. In the year 2005, what is the difference between the Expenses (% of total expenses) in Goods and services and Expenses (% of total expenses) in Subsidies and Transfers?
Make the answer very short. -25.23. In the year 2005, what is the difference between the Expenses (% of total expenses) of Goods and services and Expenses (% of total expenses) of Other expenses?
Provide a short and direct response. 7.3. In the year 2005, what is the difference between the Expenses (% of total expenses) of Subsidies and Transfers and Expenses (% of total expenses) of Other expenses?
Ensure brevity in your answer.  32.53. In the year 2006, what is the difference between the Expenses (% of total expenses) in Compensation of employees and Expenses (% of total expenses) in Goods and services?
Give a very brief answer. 7.01. In the year 2006, what is the difference between the Expenses (% of total expenses) of Compensation of employees and Expenses (% of total expenses) of Subsidies and Transfers?
Give a very brief answer. -17.76. In the year 2006, what is the difference between the Expenses (% of total expenses) of Compensation of employees and Expenses (% of total expenses) of Other expenses?
Your response must be concise. 16.1. In the year 2006, what is the difference between the Expenses (% of total expenses) in Goods and services and Expenses (% of total expenses) in Subsidies and Transfers?
Make the answer very short. -24.77. In the year 2006, what is the difference between the Expenses (% of total expenses) of Goods and services and Expenses (% of total expenses) of Other expenses?
Offer a very short reply. 9.09. In the year 2006, what is the difference between the Expenses (% of total expenses) in Subsidies and Transfers and Expenses (% of total expenses) in Other expenses?
Provide a succinct answer. 33.86. What is the ratio of the Expenses (% of total expenses) of Compensation of employees in 1995 to that in 2001?
Make the answer very short. 1.15. What is the ratio of the Expenses (% of total expenses) of Goods and services in 1995 to that in 2001?
Make the answer very short. 1.83. What is the ratio of the Expenses (% of total expenses) in Subsidies and Transfers in 1995 to that in 2001?
Your response must be concise. 1.02. What is the ratio of the Expenses (% of total expenses) in Other expenses in 1995 to that in 2001?
Make the answer very short. 1.06. What is the ratio of the Expenses (% of total expenses) in Compensation of employees in 1995 to that in 2002?
Your answer should be very brief. 1.17. What is the ratio of the Expenses (% of total expenses) in Goods and services in 1995 to that in 2002?
Provide a succinct answer. 1.89. What is the ratio of the Expenses (% of total expenses) of Other expenses in 1995 to that in 2002?
Make the answer very short. 0.95. What is the ratio of the Expenses (% of total expenses) in Compensation of employees in 1995 to that in 2003?
Your answer should be compact. 1.21. What is the ratio of the Expenses (% of total expenses) of Goods and services in 1995 to that in 2003?
Offer a terse response. 1.72. What is the ratio of the Expenses (% of total expenses) in Subsidies and Transfers in 1995 to that in 2003?
Keep it short and to the point. 1.08. What is the ratio of the Expenses (% of total expenses) in Other expenses in 1995 to that in 2003?
Your response must be concise. 0.76. What is the ratio of the Expenses (% of total expenses) in Compensation of employees in 1995 to that in 2004?
Ensure brevity in your answer.  1.12. What is the ratio of the Expenses (% of total expenses) in Goods and services in 1995 to that in 2004?
Provide a succinct answer. 1.92. What is the ratio of the Expenses (% of total expenses) of Subsidies and Transfers in 1995 to that in 2004?
Provide a short and direct response. 1.24. What is the ratio of the Expenses (% of total expenses) of Other expenses in 1995 to that in 2004?
Give a very brief answer. 0.65. What is the ratio of the Expenses (% of total expenses) in Compensation of employees in 1995 to that in 2005?
Ensure brevity in your answer.  1.15. What is the ratio of the Expenses (% of total expenses) in Goods and services in 1995 to that in 2005?
Offer a very short reply. 1.88. What is the ratio of the Expenses (% of total expenses) of Subsidies and Transfers in 1995 to that in 2005?
Provide a succinct answer. 1.19. What is the ratio of the Expenses (% of total expenses) of Other expenses in 1995 to that in 2005?
Give a very brief answer. 0.8. What is the ratio of the Expenses (% of total expenses) of Compensation of employees in 1995 to that in 2006?
Your answer should be very brief. 1.26. What is the ratio of the Expenses (% of total expenses) of Goods and services in 1995 to that in 2006?
Your response must be concise. 1.76. What is the ratio of the Expenses (% of total expenses) in Subsidies and Transfers in 1995 to that in 2006?
Your answer should be very brief. 1.18. What is the ratio of the Expenses (% of total expenses) of Other expenses in 1995 to that in 2006?
Your answer should be compact. 0.9. What is the ratio of the Expenses (% of total expenses) in Compensation of employees in 2001 to that in 2002?
Make the answer very short. 1.02. What is the ratio of the Expenses (% of total expenses) in Goods and services in 2001 to that in 2002?
Make the answer very short. 1.03. What is the ratio of the Expenses (% of total expenses) in Subsidies and Transfers in 2001 to that in 2002?
Your answer should be very brief. 1.01. What is the ratio of the Expenses (% of total expenses) in Other expenses in 2001 to that in 2002?
Provide a succinct answer. 0.9. What is the ratio of the Expenses (% of total expenses) of Compensation of employees in 2001 to that in 2003?
Keep it short and to the point. 1.05. What is the ratio of the Expenses (% of total expenses) in Goods and services in 2001 to that in 2003?
Keep it short and to the point. 0.94. What is the ratio of the Expenses (% of total expenses) in Subsidies and Transfers in 2001 to that in 2003?
Your answer should be compact. 1.06. What is the ratio of the Expenses (% of total expenses) in Other expenses in 2001 to that in 2003?
Make the answer very short. 0.72. What is the ratio of the Expenses (% of total expenses) of Compensation of employees in 2001 to that in 2004?
Offer a terse response. 0.97. What is the ratio of the Expenses (% of total expenses) of Goods and services in 2001 to that in 2004?
Keep it short and to the point. 1.05. What is the ratio of the Expenses (% of total expenses) of Subsidies and Transfers in 2001 to that in 2004?
Offer a terse response. 1.22. What is the ratio of the Expenses (% of total expenses) of Other expenses in 2001 to that in 2004?
Make the answer very short. 0.62. What is the ratio of the Expenses (% of total expenses) in Goods and services in 2001 to that in 2005?
Your response must be concise. 1.03. What is the ratio of the Expenses (% of total expenses) of Subsidies and Transfers in 2001 to that in 2005?
Offer a terse response. 1.17. What is the ratio of the Expenses (% of total expenses) in Other expenses in 2001 to that in 2005?
Offer a very short reply. 0.75. What is the ratio of the Expenses (% of total expenses) in Compensation of employees in 2001 to that in 2006?
Offer a very short reply. 1.09. What is the ratio of the Expenses (% of total expenses) in Goods and services in 2001 to that in 2006?
Provide a succinct answer. 0.96. What is the ratio of the Expenses (% of total expenses) in Subsidies and Transfers in 2001 to that in 2006?
Provide a succinct answer. 1.16. What is the ratio of the Expenses (% of total expenses) in Other expenses in 2001 to that in 2006?
Offer a very short reply. 0.85. What is the ratio of the Expenses (% of total expenses) in Compensation of employees in 2002 to that in 2003?
Make the answer very short. 1.03. What is the ratio of the Expenses (% of total expenses) of Goods and services in 2002 to that in 2003?
Ensure brevity in your answer.  0.91. What is the ratio of the Expenses (% of total expenses) in Subsidies and Transfers in 2002 to that in 2003?
Make the answer very short. 1.05. What is the ratio of the Expenses (% of total expenses) in Other expenses in 2002 to that in 2003?
Provide a short and direct response. 0.8. What is the ratio of the Expenses (% of total expenses) in Compensation of employees in 2002 to that in 2004?
Make the answer very short. 0.95. What is the ratio of the Expenses (% of total expenses) in Goods and services in 2002 to that in 2004?
Your response must be concise. 1.02. What is the ratio of the Expenses (% of total expenses) of Subsidies and Transfers in 2002 to that in 2004?
Provide a succinct answer. 1.21. What is the ratio of the Expenses (% of total expenses) of Other expenses in 2002 to that in 2004?
Make the answer very short. 0.69. What is the ratio of the Expenses (% of total expenses) in Compensation of employees in 2002 to that in 2005?
Provide a succinct answer. 0.98. What is the ratio of the Expenses (% of total expenses) of Subsidies and Transfers in 2002 to that in 2005?
Make the answer very short. 1.16. What is the ratio of the Expenses (% of total expenses) in Other expenses in 2002 to that in 2005?
Your answer should be very brief. 0.84. What is the ratio of the Expenses (% of total expenses) of Compensation of employees in 2002 to that in 2006?
Offer a very short reply. 1.07. What is the ratio of the Expenses (% of total expenses) in Goods and services in 2002 to that in 2006?
Offer a terse response. 0.93. What is the ratio of the Expenses (% of total expenses) in Subsidies and Transfers in 2002 to that in 2006?
Provide a succinct answer. 1.14. What is the ratio of the Expenses (% of total expenses) in Other expenses in 2002 to that in 2006?
Your response must be concise. 0.94. What is the ratio of the Expenses (% of total expenses) of Compensation of employees in 2003 to that in 2004?
Make the answer very short. 0.92. What is the ratio of the Expenses (% of total expenses) of Goods and services in 2003 to that in 2004?
Offer a terse response. 1.11. What is the ratio of the Expenses (% of total expenses) in Subsidies and Transfers in 2003 to that in 2004?
Your response must be concise. 1.15. What is the ratio of the Expenses (% of total expenses) of Other expenses in 2003 to that in 2004?
Your answer should be very brief. 0.86. What is the ratio of the Expenses (% of total expenses) of Compensation of employees in 2003 to that in 2005?
Your answer should be compact. 0.95. What is the ratio of the Expenses (% of total expenses) in Goods and services in 2003 to that in 2005?
Provide a short and direct response. 1.09. What is the ratio of the Expenses (% of total expenses) of Subsidies and Transfers in 2003 to that in 2005?
Your answer should be very brief. 1.11. What is the ratio of the Expenses (% of total expenses) in Other expenses in 2003 to that in 2005?
Your answer should be very brief. 1.04. What is the ratio of the Expenses (% of total expenses) in Compensation of employees in 2003 to that in 2006?
Ensure brevity in your answer.  1.04. What is the ratio of the Expenses (% of total expenses) in Goods and services in 2003 to that in 2006?
Provide a succinct answer. 1.02. What is the ratio of the Expenses (% of total expenses) of Subsidies and Transfers in 2003 to that in 2006?
Make the answer very short. 1.09. What is the ratio of the Expenses (% of total expenses) of Other expenses in 2003 to that in 2006?
Keep it short and to the point. 1.18. What is the ratio of the Expenses (% of total expenses) in Compensation of employees in 2004 to that in 2005?
Keep it short and to the point. 1.03. What is the ratio of the Expenses (% of total expenses) of Goods and services in 2004 to that in 2005?
Your answer should be compact. 0.98. What is the ratio of the Expenses (% of total expenses) of Subsidies and Transfers in 2004 to that in 2005?
Provide a short and direct response. 0.96. What is the ratio of the Expenses (% of total expenses) of Other expenses in 2004 to that in 2005?
Your answer should be compact. 1.22. What is the ratio of the Expenses (% of total expenses) in Compensation of employees in 2004 to that in 2006?
Offer a terse response. 1.12. What is the ratio of the Expenses (% of total expenses) in Goods and services in 2004 to that in 2006?
Your answer should be compact. 0.92. What is the ratio of the Expenses (% of total expenses) in Subsidies and Transfers in 2004 to that in 2006?
Keep it short and to the point. 0.95. What is the ratio of the Expenses (% of total expenses) of Other expenses in 2004 to that in 2006?
Your answer should be very brief. 1.37. What is the ratio of the Expenses (% of total expenses) in Compensation of employees in 2005 to that in 2006?
Your response must be concise. 1.09. What is the ratio of the Expenses (% of total expenses) in Goods and services in 2005 to that in 2006?
Make the answer very short. 0.94. What is the ratio of the Expenses (% of total expenses) of Subsidies and Transfers in 2005 to that in 2006?
Ensure brevity in your answer.  0.99. What is the ratio of the Expenses (% of total expenses) in Other expenses in 2005 to that in 2006?
Ensure brevity in your answer.  1.13. What is the difference between the highest and the second highest Expenses (% of total expenses) in Compensation of employees?
Ensure brevity in your answer.  2.96. What is the difference between the highest and the second highest Expenses (% of total expenses) in Goods and services?
Offer a terse response. 11.41. What is the difference between the highest and the second highest Expenses (% of total expenses) of Subsidies and Transfers?
Make the answer very short. 0.75. What is the difference between the highest and the second highest Expenses (% of total expenses) of Other expenses?
Offer a very short reply. 1.25. What is the difference between the highest and the lowest Expenses (% of total expenses) of Compensation of employees?
Make the answer very short. 5.75. What is the difference between the highest and the lowest Expenses (% of total expenses) in Goods and services?
Your answer should be very brief. 13.02. What is the difference between the highest and the lowest Expenses (% of total expenses) of Subsidies and Transfers?
Ensure brevity in your answer.  9.26. What is the difference between the highest and the lowest Expenses (% of total expenses) of Other expenses?
Your answer should be compact. 3.33. 